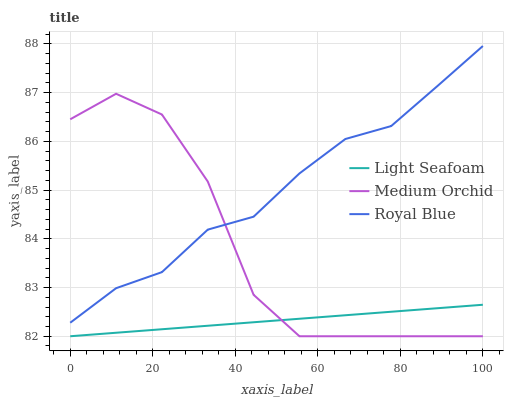Does Light Seafoam have the minimum area under the curve?
Answer yes or no. Yes. Does Royal Blue have the maximum area under the curve?
Answer yes or no. Yes. Does Medium Orchid have the minimum area under the curve?
Answer yes or no. No. Does Medium Orchid have the maximum area under the curve?
Answer yes or no. No. Is Light Seafoam the smoothest?
Answer yes or no. Yes. Is Medium Orchid the roughest?
Answer yes or no. Yes. Is Medium Orchid the smoothest?
Answer yes or no. No. Is Light Seafoam the roughest?
Answer yes or no. No. Does Medium Orchid have the lowest value?
Answer yes or no. Yes. Does Royal Blue have the highest value?
Answer yes or no. Yes. Does Medium Orchid have the highest value?
Answer yes or no. No. Is Light Seafoam less than Royal Blue?
Answer yes or no. Yes. Is Royal Blue greater than Light Seafoam?
Answer yes or no. Yes. Does Medium Orchid intersect Royal Blue?
Answer yes or no. Yes. Is Medium Orchid less than Royal Blue?
Answer yes or no. No. Is Medium Orchid greater than Royal Blue?
Answer yes or no. No. Does Light Seafoam intersect Royal Blue?
Answer yes or no. No. 